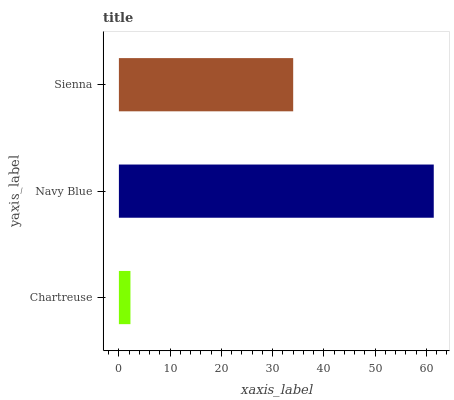Is Chartreuse the minimum?
Answer yes or no. Yes. Is Navy Blue the maximum?
Answer yes or no. Yes. Is Sienna the minimum?
Answer yes or no. No. Is Sienna the maximum?
Answer yes or no. No. Is Navy Blue greater than Sienna?
Answer yes or no. Yes. Is Sienna less than Navy Blue?
Answer yes or no. Yes. Is Sienna greater than Navy Blue?
Answer yes or no. No. Is Navy Blue less than Sienna?
Answer yes or no. No. Is Sienna the high median?
Answer yes or no. Yes. Is Sienna the low median?
Answer yes or no. Yes. Is Navy Blue the high median?
Answer yes or no. No. Is Chartreuse the low median?
Answer yes or no. No. 